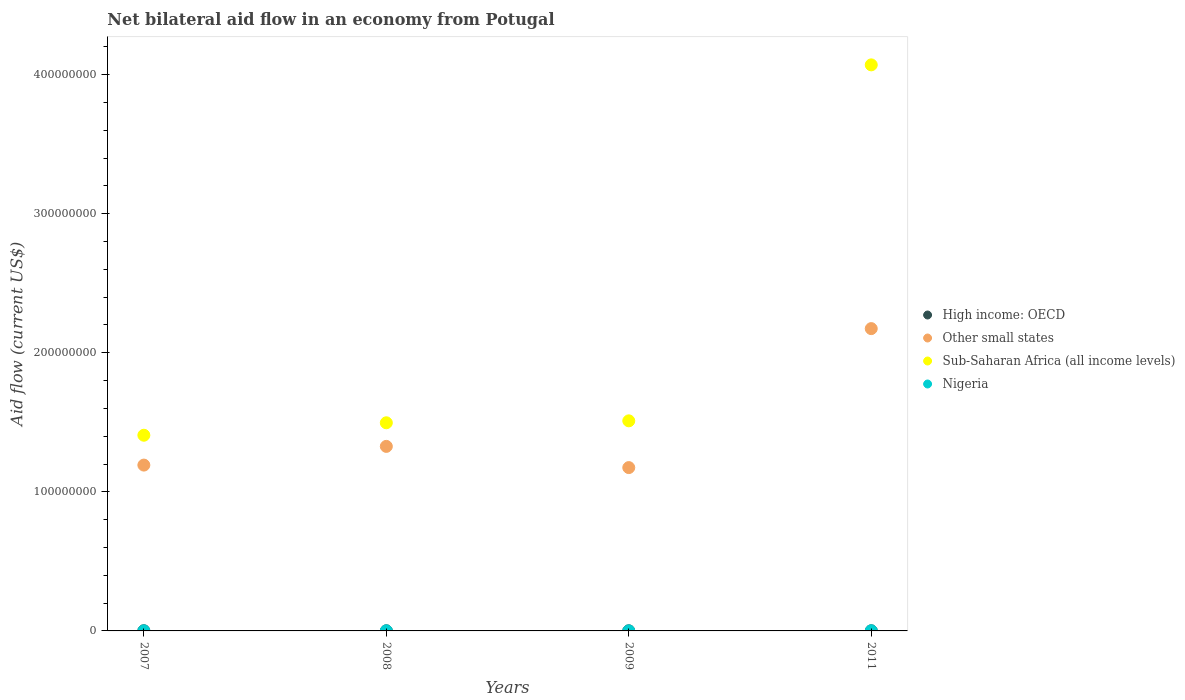How many different coloured dotlines are there?
Give a very brief answer. 4. Across all years, what is the maximum net bilateral aid flow in Sub-Saharan Africa (all income levels)?
Make the answer very short. 4.07e+08. Across all years, what is the minimum net bilateral aid flow in High income: OECD?
Keep it short and to the point. 9.00e+04. In which year was the net bilateral aid flow in High income: OECD minimum?
Make the answer very short. 2009. What is the total net bilateral aid flow in Other small states in the graph?
Ensure brevity in your answer.  5.87e+08. What is the difference between the net bilateral aid flow in Sub-Saharan Africa (all income levels) in 2007 and that in 2009?
Give a very brief answer. -1.04e+07. What is the difference between the net bilateral aid flow in Sub-Saharan Africa (all income levels) in 2008 and the net bilateral aid flow in Nigeria in 2007?
Offer a very short reply. 1.50e+08. What is the average net bilateral aid flow in High income: OECD per year?
Make the answer very short. 1.02e+05. In the year 2009, what is the difference between the net bilateral aid flow in Other small states and net bilateral aid flow in Nigeria?
Keep it short and to the point. 1.17e+08. What is the ratio of the net bilateral aid flow in Other small states in 2008 to that in 2009?
Keep it short and to the point. 1.13. What is the difference between the highest and the second highest net bilateral aid flow in Other small states?
Ensure brevity in your answer.  8.47e+07. What is the difference between the highest and the lowest net bilateral aid flow in Sub-Saharan Africa (all income levels)?
Your response must be concise. 2.66e+08. In how many years, is the net bilateral aid flow in Other small states greater than the average net bilateral aid flow in Other small states taken over all years?
Your answer should be compact. 1. Does the net bilateral aid flow in Nigeria monotonically increase over the years?
Keep it short and to the point. No. Does the graph contain any zero values?
Provide a succinct answer. No. Does the graph contain grids?
Offer a terse response. No. Where does the legend appear in the graph?
Keep it short and to the point. Center right. How are the legend labels stacked?
Provide a short and direct response. Vertical. What is the title of the graph?
Your answer should be compact. Net bilateral aid flow in an economy from Potugal. What is the label or title of the X-axis?
Make the answer very short. Years. What is the label or title of the Y-axis?
Make the answer very short. Aid flow (current US$). What is the Aid flow (current US$) in High income: OECD in 2007?
Give a very brief answer. 1.30e+05. What is the Aid flow (current US$) of Other small states in 2007?
Give a very brief answer. 1.19e+08. What is the Aid flow (current US$) of Sub-Saharan Africa (all income levels) in 2007?
Provide a succinct answer. 1.41e+08. What is the Aid flow (current US$) in Other small states in 2008?
Offer a terse response. 1.33e+08. What is the Aid flow (current US$) in Sub-Saharan Africa (all income levels) in 2008?
Your answer should be compact. 1.50e+08. What is the Aid flow (current US$) of Nigeria in 2008?
Provide a short and direct response. 8.00e+04. What is the Aid flow (current US$) of High income: OECD in 2009?
Offer a very short reply. 9.00e+04. What is the Aid flow (current US$) of Other small states in 2009?
Give a very brief answer. 1.17e+08. What is the Aid flow (current US$) of Sub-Saharan Africa (all income levels) in 2009?
Ensure brevity in your answer.  1.51e+08. What is the Aid flow (current US$) of High income: OECD in 2011?
Provide a succinct answer. 9.00e+04. What is the Aid flow (current US$) of Other small states in 2011?
Offer a terse response. 2.17e+08. What is the Aid flow (current US$) of Sub-Saharan Africa (all income levels) in 2011?
Your answer should be very brief. 4.07e+08. What is the Aid flow (current US$) in Nigeria in 2011?
Offer a terse response. 1.10e+05. Across all years, what is the maximum Aid flow (current US$) in Other small states?
Keep it short and to the point. 2.17e+08. Across all years, what is the maximum Aid flow (current US$) in Sub-Saharan Africa (all income levels)?
Your response must be concise. 4.07e+08. Across all years, what is the minimum Aid flow (current US$) in Other small states?
Make the answer very short. 1.17e+08. Across all years, what is the minimum Aid flow (current US$) of Sub-Saharan Africa (all income levels)?
Give a very brief answer. 1.41e+08. Across all years, what is the minimum Aid flow (current US$) in Nigeria?
Provide a short and direct response. 4.00e+04. What is the total Aid flow (current US$) of Other small states in the graph?
Keep it short and to the point. 5.87e+08. What is the total Aid flow (current US$) of Sub-Saharan Africa (all income levels) in the graph?
Your answer should be very brief. 8.49e+08. What is the difference between the Aid flow (current US$) in High income: OECD in 2007 and that in 2008?
Provide a succinct answer. 3.00e+04. What is the difference between the Aid flow (current US$) of Other small states in 2007 and that in 2008?
Your answer should be very brief. -1.34e+07. What is the difference between the Aid flow (current US$) in Sub-Saharan Africa (all income levels) in 2007 and that in 2008?
Offer a terse response. -8.95e+06. What is the difference between the Aid flow (current US$) of Nigeria in 2007 and that in 2008?
Provide a short and direct response. -10000. What is the difference between the Aid flow (current US$) of Other small states in 2007 and that in 2009?
Provide a succinct answer. 1.80e+06. What is the difference between the Aid flow (current US$) in Sub-Saharan Africa (all income levels) in 2007 and that in 2009?
Ensure brevity in your answer.  -1.04e+07. What is the difference between the Aid flow (current US$) in High income: OECD in 2007 and that in 2011?
Your response must be concise. 4.00e+04. What is the difference between the Aid flow (current US$) in Other small states in 2007 and that in 2011?
Your response must be concise. -9.81e+07. What is the difference between the Aid flow (current US$) in Sub-Saharan Africa (all income levels) in 2007 and that in 2011?
Your answer should be compact. -2.66e+08. What is the difference between the Aid flow (current US$) in High income: OECD in 2008 and that in 2009?
Provide a succinct answer. 10000. What is the difference between the Aid flow (current US$) of Other small states in 2008 and that in 2009?
Make the answer very short. 1.52e+07. What is the difference between the Aid flow (current US$) of Sub-Saharan Africa (all income levels) in 2008 and that in 2009?
Ensure brevity in your answer.  -1.40e+06. What is the difference between the Aid flow (current US$) of Nigeria in 2008 and that in 2009?
Provide a succinct answer. 4.00e+04. What is the difference between the Aid flow (current US$) in High income: OECD in 2008 and that in 2011?
Provide a succinct answer. 10000. What is the difference between the Aid flow (current US$) of Other small states in 2008 and that in 2011?
Keep it short and to the point. -8.47e+07. What is the difference between the Aid flow (current US$) in Sub-Saharan Africa (all income levels) in 2008 and that in 2011?
Your response must be concise. -2.57e+08. What is the difference between the Aid flow (current US$) of Nigeria in 2008 and that in 2011?
Make the answer very short. -3.00e+04. What is the difference between the Aid flow (current US$) of High income: OECD in 2009 and that in 2011?
Provide a short and direct response. 0. What is the difference between the Aid flow (current US$) in Other small states in 2009 and that in 2011?
Give a very brief answer. -9.99e+07. What is the difference between the Aid flow (current US$) of Sub-Saharan Africa (all income levels) in 2009 and that in 2011?
Your response must be concise. -2.56e+08. What is the difference between the Aid flow (current US$) of High income: OECD in 2007 and the Aid flow (current US$) of Other small states in 2008?
Provide a short and direct response. -1.33e+08. What is the difference between the Aid flow (current US$) in High income: OECD in 2007 and the Aid flow (current US$) in Sub-Saharan Africa (all income levels) in 2008?
Make the answer very short. -1.50e+08. What is the difference between the Aid flow (current US$) in High income: OECD in 2007 and the Aid flow (current US$) in Nigeria in 2008?
Your answer should be very brief. 5.00e+04. What is the difference between the Aid flow (current US$) of Other small states in 2007 and the Aid flow (current US$) of Sub-Saharan Africa (all income levels) in 2008?
Make the answer very short. -3.04e+07. What is the difference between the Aid flow (current US$) in Other small states in 2007 and the Aid flow (current US$) in Nigeria in 2008?
Keep it short and to the point. 1.19e+08. What is the difference between the Aid flow (current US$) of Sub-Saharan Africa (all income levels) in 2007 and the Aid flow (current US$) of Nigeria in 2008?
Offer a very short reply. 1.41e+08. What is the difference between the Aid flow (current US$) in High income: OECD in 2007 and the Aid flow (current US$) in Other small states in 2009?
Make the answer very short. -1.17e+08. What is the difference between the Aid flow (current US$) of High income: OECD in 2007 and the Aid flow (current US$) of Sub-Saharan Africa (all income levels) in 2009?
Offer a terse response. -1.51e+08. What is the difference between the Aid flow (current US$) in High income: OECD in 2007 and the Aid flow (current US$) in Nigeria in 2009?
Offer a very short reply. 9.00e+04. What is the difference between the Aid flow (current US$) of Other small states in 2007 and the Aid flow (current US$) of Sub-Saharan Africa (all income levels) in 2009?
Offer a very short reply. -3.18e+07. What is the difference between the Aid flow (current US$) of Other small states in 2007 and the Aid flow (current US$) of Nigeria in 2009?
Ensure brevity in your answer.  1.19e+08. What is the difference between the Aid flow (current US$) in Sub-Saharan Africa (all income levels) in 2007 and the Aid flow (current US$) in Nigeria in 2009?
Make the answer very short. 1.41e+08. What is the difference between the Aid flow (current US$) in High income: OECD in 2007 and the Aid flow (current US$) in Other small states in 2011?
Make the answer very short. -2.17e+08. What is the difference between the Aid flow (current US$) of High income: OECD in 2007 and the Aid flow (current US$) of Sub-Saharan Africa (all income levels) in 2011?
Ensure brevity in your answer.  -4.07e+08. What is the difference between the Aid flow (current US$) of High income: OECD in 2007 and the Aid flow (current US$) of Nigeria in 2011?
Offer a terse response. 2.00e+04. What is the difference between the Aid flow (current US$) of Other small states in 2007 and the Aid flow (current US$) of Sub-Saharan Africa (all income levels) in 2011?
Keep it short and to the point. -2.88e+08. What is the difference between the Aid flow (current US$) in Other small states in 2007 and the Aid flow (current US$) in Nigeria in 2011?
Offer a terse response. 1.19e+08. What is the difference between the Aid flow (current US$) of Sub-Saharan Africa (all income levels) in 2007 and the Aid flow (current US$) of Nigeria in 2011?
Provide a succinct answer. 1.41e+08. What is the difference between the Aid flow (current US$) in High income: OECD in 2008 and the Aid flow (current US$) in Other small states in 2009?
Keep it short and to the point. -1.17e+08. What is the difference between the Aid flow (current US$) of High income: OECD in 2008 and the Aid flow (current US$) of Sub-Saharan Africa (all income levels) in 2009?
Provide a succinct answer. -1.51e+08. What is the difference between the Aid flow (current US$) of Other small states in 2008 and the Aid flow (current US$) of Sub-Saharan Africa (all income levels) in 2009?
Offer a terse response. -1.84e+07. What is the difference between the Aid flow (current US$) in Other small states in 2008 and the Aid flow (current US$) in Nigeria in 2009?
Provide a succinct answer. 1.33e+08. What is the difference between the Aid flow (current US$) in Sub-Saharan Africa (all income levels) in 2008 and the Aid flow (current US$) in Nigeria in 2009?
Your answer should be compact. 1.50e+08. What is the difference between the Aid flow (current US$) of High income: OECD in 2008 and the Aid flow (current US$) of Other small states in 2011?
Your answer should be compact. -2.17e+08. What is the difference between the Aid flow (current US$) of High income: OECD in 2008 and the Aid flow (current US$) of Sub-Saharan Africa (all income levels) in 2011?
Make the answer very short. -4.07e+08. What is the difference between the Aid flow (current US$) of Other small states in 2008 and the Aid flow (current US$) of Sub-Saharan Africa (all income levels) in 2011?
Your answer should be very brief. -2.74e+08. What is the difference between the Aid flow (current US$) of Other small states in 2008 and the Aid flow (current US$) of Nigeria in 2011?
Offer a very short reply. 1.33e+08. What is the difference between the Aid flow (current US$) of Sub-Saharan Africa (all income levels) in 2008 and the Aid flow (current US$) of Nigeria in 2011?
Provide a succinct answer. 1.50e+08. What is the difference between the Aid flow (current US$) of High income: OECD in 2009 and the Aid flow (current US$) of Other small states in 2011?
Keep it short and to the point. -2.17e+08. What is the difference between the Aid flow (current US$) in High income: OECD in 2009 and the Aid flow (current US$) in Sub-Saharan Africa (all income levels) in 2011?
Offer a very short reply. -4.07e+08. What is the difference between the Aid flow (current US$) of Other small states in 2009 and the Aid flow (current US$) of Sub-Saharan Africa (all income levels) in 2011?
Offer a very short reply. -2.90e+08. What is the difference between the Aid flow (current US$) in Other small states in 2009 and the Aid flow (current US$) in Nigeria in 2011?
Offer a very short reply. 1.17e+08. What is the difference between the Aid flow (current US$) of Sub-Saharan Africa (all income levels) in 2009 and the Aid flow (current US$) of Nigeria in 2011?
Offer a terse response. 1.51e+08. What is the average Aid flow (current US$) in High income: OECD per year?
Provide a succinct answer. 1.02e+05. What is the average Aid flow (current US$) of Other small states per year?
Keep it short and to the point. 1.47e+08. What is the average Aid flow (current US$) of Sub-Saharan Africa (all income levels) per year?
Provide a succinct answer. 2.12e+08. What is the average Aid flow (current US$) of Nigeria per year?
Provide a short and direct response. 7.50e+04. In the year 2007, what is the difference between the Aid flow (current US$) of High income: OECD and Aid flow (current US$) of Other small states?
Keep it short and to the point. -1.19e+08. In the year 2007, what is the difference between the Aid flow (current US$) in High income: OECD and Aid flow (current US$) in Sub-Saharan Africa (all income levels)?
Offer a very short reply. -1.41e+08. In the year 2007, what is the difference between the Aid flow (current US$) in Other small states and Aid flow (current US$) in Sub-Saharan Africa (all income levels)?
Offer a terse response. -2.15e+07. In the year 2007, what is the difference between the Aid flow (current US$) in Other small states and Aid flow (current US$) in Nigeria?
Provide a succinct answer. 1.19e+08. In the year 2007, what is the difference between the Aid flow (current US$) in Sub-Saharan Africa (all income levels) and Aid flow (current US$) in Nigeria?
Give a very brief answer. 1.41e+08. In the year 2008, what is the difference between the Aid flow (current US$) of High income: OECD and Aid flow (current US$) of Other small states?
Offer a very short reply. -1.33e+08. In the year 2008, what is the difference between the Aid flow (current US$) of High income: OECD and Aid flow (current US$) of Sub-Saharan Africa (all income levels)?
Your answer should be very brief. -1.50e+08. In the year 2008, what is the difference between the Aid flow (current US$) in Other small states and Aid flow (current US$) in Sub-Saharan Africa (all income levels)?
Your answer should be compact. -1.70e+07. In the year 2008, what is the difference between the Aid flow (current US$) of Other small states and Aid flow (current US$) of Nigeria?
Your answer should be very brief. 1.33e+08. In the year 2008, what is the difference between the Aid flow (current US$) of Sub-Saharan Africa (all income levels) and Aid flow (current US$) of Nigeria?
Your response must be concise. 1.50e+08. In the year 2009, what is the difference between the Aid flow (current US$) in High income: OECD and Aid flow (current US$) in Other small states?
Provide a succinct answer. -1.17e+08. In the year 2009, what is the difference between the Aid flow (current US$) of High income: OECD and Aid flow (current US$) of Sub-Saharan Africa (all income levels)?
Provide a short and direct response. -1.51e+08. In the year 2009, what is the difference between the Aid flow (current US$) in High income: OECD and Aid flow (current US$) in Nigeria?
Your answer should be compact. 5.00e+04. In the year 2009, what is the difference between the Aid flow (current US$) of Other small states and Aid flow (current US$) of Sub-Saharan Africa (all income levels)?
Your answer should be compact. -3.36e+07. In the year 2009, what is the difference between the Aid flow (current US$) in Other small states and Aid flow (current US$) in Nigeria?
Provide a short and direct response. 1.17e+08. In the year 2009, what is the difference between the Aid flow (current US$) in Sub-Saharan Africa (all income levels) and Aid flow (current US$) in Nigeria?
Give a very brief answer. 1.51e+08. In the year 2011, what is the difference between the Aid flow (current US$) in High income: OECD and Aid flow (current US$) in Other small states?
Offer a very short reply. -2.17e+08. In the year 2011, what is the difference between the Aid flow (current US$) in High income: OECD and Aid flow (current US$) in Sub-Saharan Africa (all income levels)?
Your answer should be very brief. -4.07e+08. In the year 2011, what is the difference between the Aid flow (current US$) in High income: OECD and Aid flow (current US$) in Nigeria?
Offer a very short reply. -2.00e+04. In the year 2011, what is the difference between the Aid flow (current US$) in Other small states and Aid flow (current US$) in Sub-Saharan Africa (all income levels)?
Give a very brief answer. -1.90e+08. In the year 2011, what is the difference between the Aid flow (current US$) of Other small states and Aid flow (current US$) of Nigeria?
Your answer should be very brief. 2.17e+08. In the year 2011, what is the difference between the Aid flow (current US$) of Sub-Saharan Africa (all income levels) and Aid flow (current US$) of Nigeria?
Provide a short and direct response. 4.07e+08. What is the ratio of the Aid flow (current US$) in High income: OECD in 2007 to that in 2008?
Ensure brevity in your answer.  1.3. What is the ratio of the Aid flow (current US$) in Other small states in 2007 to that in 2008?
Keep it short and to the point. 0.9. What is the ratio of the Aid flow (current US$) in Sub-Saharan Africa (all income levels) in 2007 to that in 2008?
Make the answer very short. 0.94. What is the ratio of the Aid flow (current US$) of Nigeria in 2007 to that in 2008?
Make the answer very short. 0.88. What is the ratio of the Aid flow (current US$) of High income: OECD in 2007 to that in 2009?
Give a very brief answer. 1.44. What is the ratio of the Aid flow (current US$) of Other small states in 2007 to that in 2009?
Your answer should be compact. 1.02. What is the ratio of the Aid flow (current US$) in Sub-Saharan Africa (all income levels) in 2007 to that in 2009?
Provide a short and direct response. 0.93. What is the ratio of the Aid flow (current US$) in High income: OECD in 2007 to that in 2011?
Offer a terse response. 1.44. What is the ratio of the Aid flow (current US$) of Other small states in 2007 to that in 2011?
Keep it short and to the point. 0.55. What is the ratio of the Aid flow (current US$) of Sub-Saharan Africa (all income levels) in 2007 to that in 2011?
Keep it short and to the point. 0.35. What is the ratio of the Aid flow (current US$) of Nigeria in 2007 to that in 2011?
Give a very brief answer. 0.64. What is the ratio of the Aid flow (current US$) in Other small states in 2008 to that in 2009?
Ensure brevity in your answer.  1.13. What is the ratio of the Aid flow (current US$) of Sub-Saharan Africa (all income levels) in 2008 to that in 2009?
Offer a terse response. 0.99. What is the ratio of the Aid flow (current US$) in Other small states in 2008 to that in 2011?
Keep it short and to the point. 0.61. What is the ratio of the Aid flow (current US$) of Sub-Saharan Africa (all income levels) in 2008 to that in 2011?
Provide a short and direct response. 0.37. What is the ratio of the Aid flow (current US$) in Nigeria in 2008 to that in 2011?
Offer a very short reply. 0.73. What is the ratio of the Aid flow (current US$) in Other small states in 2009 to that in 2011?
Ensure brevity in your answer.  0.54. What is the ratio of the Aid flow (current US$) of Sub-Saharan Africa (all income levels) in 2009 to that in 2011?
Your answer should be compact. 0.37. What is the ratio of the Aid flow (current US$) of Nigeria in 2009 to that in 2011?
Your response must be concise. 0.36. What is the difference between the highest and the second highest Aid flow (current US$) in High income: OECD?
Your answer should be compact. 3.00e+04. What is the difference between the highest and the second highest Aid flow (current US$) in Other small states?
Offer a terse response. 8.47e+07. What is the difference between the highest and the second highest Aid flow (current US$) of Sub-Saharan Africa (all income levels)?
Your answer should be very brief. 2.56e+08. What is the difference between the highest and the second highest Aid flow (current US$) of Nigeria?
Ensure brevity in your answer.  3.00e+04. What is the difference between the highest and the lowest Aid flow (current US$) of Other small states?
Offer a terse response. 9.99e+07. What is the difference between the highest and the lowest Aid flow (current US$) of Sub-Saharan Africa (all income levels)?
Keep it short and to the point. 2.66e+08. 